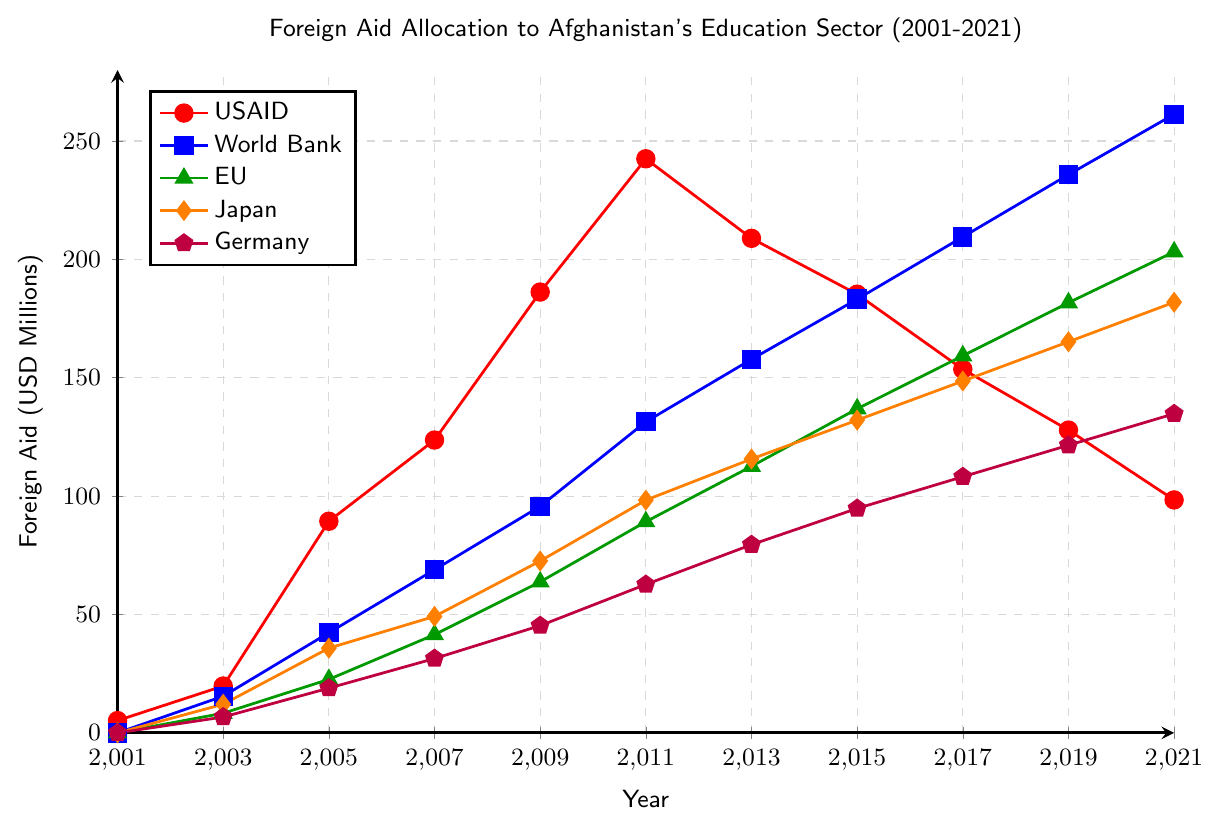What was the trend in USAID's foreign aid allocation to Afghanistan's education sector from 2001 to 2021? By observing the red line representing USAID, it is clear that the aid allocation increased significantly from 2001, peaked around 2011, and then showed a declining trend until 2021.
Answer: Increasing trend till 2011, then decreasing till 2021 Which donor showed the most consistent increase in aid allocation over the years? By comparing the trends, the blue line representing the World Bank shows a consistent increase in aid allocation from 2001 to 2021 without a significant drop.
Answer: World Bank In which year did Germany first allocate more than 100 million USD in aid? The purple line representing Germany first crosses the 100 million USD mark around the year 2017.
Answer: 2017 How much was the total aid allocated by the USAID and the World Bank in 2011? According to the figure, USAID allocated 242.5 million USD and the World Bank allocated 131.4 million USD in 2011. Adding these two values gives a total of 373.9 million USD.
Answer: 373.9 million USD Which two donors had a similar aid allocation trend around 2007? By comparing the line trends around 2007, the green line for the EU and the orange line for Japan show similar rising patterns and values.
Answer: EU and Japan By how much did the EU’s aid allocation increase from 2005 to 2015? The EU allocated 22.6 million USD in 2005 and 136.9 million USD in 2015. The difference is 136.9 - 22.6 = 114.3 million USD.
Answer: 114.3 million USD Between 2001 and 2021, which donor showed the highest fluctuation in their aid allocation values? By observing the line graphs, USAID (red line) shows the highest fluctuation with significant peaks and troughs, especially from 2005 to 2015.
Answer: USAID Which donor had the lowest aid allocation in 2003? By comparing the first segment of each line in 2003, the World Bank allocated 15.5 million USD, while the EU, Japan, and Germany allocated 8.3 million, 12.1 million, and 6.7 million respectively. Hence, Germany had the lowest allocation.
Answer: Germany How many years did it take for Japan's aid to surpass 100 million USD since 2001? Observing the orange line, Japan's aid allocation surpasses the 100 million USD mark just after 2011. This is approximately 10 years from 2001.
Answer: Around 10 years What was the difference between Germany's aid allocation and the World Bank's in 2021? In 2021, Germany's aid was 134.8 million USD while the World Bank's aid was 261.3 million USD. The difference is 261.3 - 134.8 = 126.5 million USD.
Answer: 126.5 million USD 